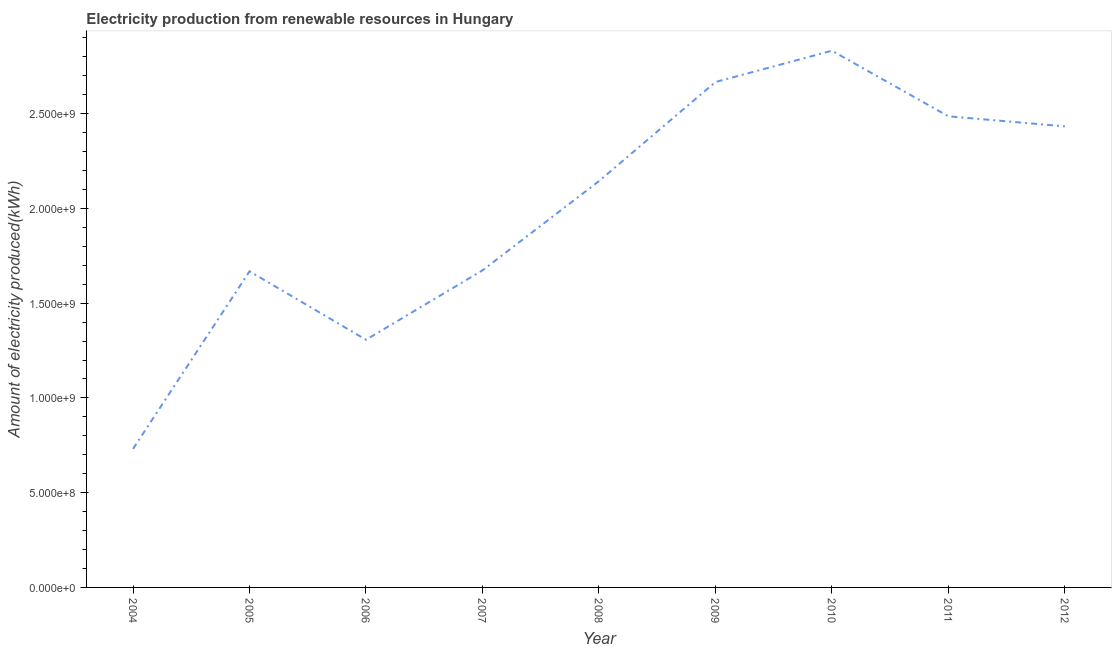What is the amount of electricity produced in 2006?
Make the answer very short. 1.31e+09. Across all years, what is the maximum amount of electricity produced?
Make the answer very short. 2.83e+09. Across all years, what is the minimum amount of electricity produced?
Provide a succinct answer. 7.31e+08. In which year was the amount of electricity produced minimum?
Give a very brief answer. 2004. What is the sum of the amount of electricity produced?
Provide a short and direct response. 1.79e+1. What is the difference between the amount of electricity produced in 2010 and 2012?
Your response must be concise. 3.99e+08. What is the average amount of electricity produced per year?
Provide a succinct answer. 1.99e+09. What is the median amount of electricity produced?
Provide a short and direct response. 2.14e+09. What is the ratio of the amount of electricity produced in 2004 to that in 2006?
Make the answer very short. 0.56. Is the amount of electricity produced in 2007 less than that in 2008?
Offer a very short reply. Yes. Is the difference between the amount of electricity produced in 2005 and 2007 greater than the difference between any two years?
Make the answer very short. No. What is the difference between the highest and the second highest amount of electricity produced?
Keep it short and to the point. 1.65e+08. What is the difference between the highest and the lowest amount of electricity produced?
Keep it short and to the point. 2.10e+09. In how many years, is the amount of electricity produced greater than the average amount of electricity produced taken over all years?
Give a very brief answer. 5. Does the amount of electricity produced monotonically increase over the years?
Your answer should be compact. No. Does the graph contain any zero values?
Give a very brief answer. No. What is the title of the graph?
Offer a terse response. Electricity production from renewable resources in Hungary. What is the label or title of the Y-axis?
Give a very brief answer. Amount of electricity produced(kWh). What is the Amount of electricity produced(kWh) in 2004?
Give a very brief answer. 7.31e+08. What is the Amount of electricity produced(kWh) in 2005?
Keep it short and to the point. 1.67e+09. What is the Amount of electricity produced(kWh) of 2006?
Your answer should be compact. 1.31e+09. What is the Amount of electricity produced(kWh) of 2007?
Give a very brief answer. 1.67e+09. What is the Amount of electricity produced(kWh) in 2008?
Your answer should be very brief. 2.14e+09. What is the Amount of electricity produced(kWh) in 2009?
Keep it short and to the point. 2.67e+09. What is the Amount of electricity produced(kWh) of 2010?
Give a very brief answer. 2.83e+09. What is the Amount of electricity produced(kWh) of 2011?
Give a very brief answer. 2.49e+09. What is the Amount of electricity produced(kWh) in 2012?
Provide a succinct answer. 2.43e+09. What is the difference between the Amount of electricity produced(kWh) in 2004 and 2005?
Your response must be concise. -9.37e+08. What is the difference between the Amount of electricity produced(kWh) in 2004 and 2006?
Provide a succinct answer. -5.76e+08. What is the difference between the Amount of electricity produced(kWh) in 2004 and 2007?
Your answer should be very brief. -9.42e+08. What is the difference between the Amount of electricity produced(kWh) in 2004 and 2008?
Ensure brevity in your answer.  -1.41e+09. What is the difference between the Amount of electricity produced(kWh) in 2004 and 2009?
Give a very brief answer. -1.94e+09. What is the difference between the Amount of electricity produced(kWh) in 2004 and 2010?
Provide a short and direct response. -2.10e+09. What is the difference between the Amount of electricity produced(kWh) in 2004 and 2011?
Offer a terse response. -1.76e+09. What is the difference between the Amount of electricity produced(kWh) in 2004 and 2012?
Your response must be concise. -1.70e+09. What is the difference between the Amount of electricity produced(kWh) in 2005 and 2006?
Your response must be concise. 3.61e+08. What is the difference between the Amount of electricity produced(kWh) in 2005 and 2007?
Give a very brief answer. -5.00e+06. What is the difference between the Amount of electricity produced(kWh) in 2005 and 2008?
Make the answer very short. -4.76e+08. What is the difference between the Amount of electricity produced(kWh) in 2005 and 2009?
Your response must be concise. -9.99e+08. What is the difference between the Amount of electricity produced(kWh) in 2005 and 2010?
Keep it short and to the point. -1.16e+09. What is the difference between the Amount of electricity produced(kWh) in 2005 and 2011?
Your response must be concise. -8.18e+08. What is the difference between the Amount of electricity produced(kWh) in 2005 and 2012?
Your answer should be very brief. -7.65e+08. What is the difference between the Amount of electricity produced(kWh) in 2006 and 2007?
Give a very brief answer. -3.66e+08. What is the difference between the Amount of electricity produced(kWh) in 2006 and 2008?
Provide a succinct answer. -8.37e+08. What is the difference between the Amount of electricity produced(kWh) in 2006 and 2009?
Keep it short and to the point. -1.36e+09. What is the difference between the Amount of electricity produced(kWh) in 2006 and 2010?
Provide a succinct answer. -1.52e+09. What is the difference between the Amount of electricity produced(kWh) in 2006 and 2011?
Offer a very short reply. -1.18e+09. What is the difference between the Amount of electricity produced(kWh) in 2006 and 2012?
Offer a terse response. -1.13e+09. What is the difference between the Amount of electricity produced(kWh) in 2007 and 2008?
Ensure brevity in your answer.  -4.71e+08. What is the difference between the Amount of electricity produced(kWh) in 2007 and 2009?
Your answer should be compact. -9.94e+08. What is the difference between the Amount of electricity produced(kWh) in 2007 and 2010?
Provide a short and direct response. -1.16e+09. What is the difference between the Amount of electricity produced(kWh) in 2007 and 2011?
Offer a terse response. -8.13e+08. What is the difference between the Amount of electricity produced(kWh) in 2007 and 2012?
Your answer should be very brief. -7.60e+08. What is the difference between the Amount of electricity produced(kWh) in 2008 and 2009?
Make the answer very short. -5.23e+08. What is the difference between the Amount of electricity produced(kWh) in 2008 and 2010?
Keep it short and to the point. -6.88e+08. What is the difference between the Amount of electricity produced(kWh) in 2008 and 2011?
Your answer should be very brief. -3.42e+08. What is the difference between the Amount of electricity produced(kWh) in 2008 and 2012?
Offer a terse response. -2.89e+08. What is the difference between the Amount of electricity produced(kWh) in 2009 and 2010?
Your answer should be very brief. -1.65e+08. What is the difference between the Amount of electricity produced(kWh) in 2009 and 2011?
Your response must be concise. 1.81e+08. What is the difference between the Amount of electricity produced(kWh) in 2009 and 2012?
Keep it short and to the point. 2.34e+08. What is the difference between the Amount of electricity produced(kWh) in 2010 and 2011?
Your answer should be compact. 3.46e+08. What is the difference between the Amount of electricity produced(kWh) in 2010 and 2012?
Ensure brevity in your answer.  3.99e+08. What is the difference between the Amount of electricity produced(kWh) in 2011 and 2012?
Your answer should be very brief. 5.30e+07. What is the ratio of the Amount of electricity produced(kWh) in 2004 to that in 2005?
Keep it short and to the point. 0.44. What is the ratio of the Amount of electricity produced(kWh) in 2004 to that in 2006?
Your answer should be compact. 0.56. What is the ratio of the Amount of electricity produced(kWh) in 2004 to that in 2007?
Provide a succinct answer. 0.44. What is the ratio of the Amount of electricity produced(kWh) in 2004 to that in 2008?
Your answer should be compact. 0.34. What is the ratio of the Amount of electricity produced(kWh) in 2004 to that in 2009?
Make the answer very short. 0.27. What is the ratio of the Amount of electricity produced(kWh) in 2004 to that in 2010?
Make the answer very short. 0.26. What is the ratio of the Amount of electricity produced(kWh) in 2004 to that in 2011?
Make the answer very short. 0.29. What is the ratio of the Amount of electricity produced(kWh) in 2005 to that in 2006?
Keep it short and to the point. 1.28. What is the ratio of the Amount of electricity produced(kWh) in 2005 to that in 2007?
Offer a very short reply. 1. What is the ratio of the Amount of electricity produced(kWh) in 2005 to that in 2008?
Your response must be concise. 0.78. What is the ratio of the Amount of electricity produced(kWh) in 2005 to that in 2009?
Keep it short and to the point. 0.62. What is the ratio of the Amount of electricity produced(kWh) in 2005 to that in 2010?
Offer a very short reply. 0.59. What is the ratio of the Amount of electricity produced(kWh) in 2005 to that in 2011?
Give a very brief answer. 0.67. What is the ratio of the Amount of electricity produced(kWh) in 2005 to that in 2012?
Provide a short and direct response. 0.69. What is the ratio of the Amount of electricity produced(kWh) in 2006 to that in 2007?
Ensure brevity in your answer.  0.78. What is the ratio of the Amount of electricity produced(kWh) in 2006 to that in 2008?
Offer a terse response. 0.61. What is the ratio of the Amount of electricity produced(kWh) in 2006 to that in 2009?
Offer a terse response. 0.49. What is the ratio of the Amount of electricity produced(kWh) in 2006 to that in 2010?
Offer a terse response. 0.46. What is the ratio of the Amount of electricity produced(kWh) in 2006 to that in 2011?
Offer a very short reply. 0.53. What is the ratio of the Amount of electricity produced(kWh) in 2006 to that in 2012?
Your answer should be compact. 0.54. What is the ratio of the Amount of electricity produced(kWh) in 2007 to that in 2008?
Offer a very short reply. 0.78. What is the ratio of the Amount of electricity produced(kWh) in 2007 to that in 2009?
Your response must be concise. 0.63. What is the ratio of the Amount of electricity produced(kWh) in 2007 to that in 2010?
Make the answer very short. 0.59. What is the ratio of the Amount of electricity produced(kWh) in 2007 to that in 2011?
Provide a succinct answer. 0.67. What is the ratio of the Amount of electricity produced(kWh) in 2007 to that in 2012?
Give a very brief answer. 0.69. What is the ratio of the Amount of electricity produced(kWh) in 2008 to that in 2009?
Your answer should be compact. 0.8. What is the ratio of the Amount of electricity produced(kWh) in 2008 to that in 2010?
Your response must be concise. 0.76. What is the ratio of the Amount of electricity produced(kWh) in 2008 to that in 2011?
Your answer should be very brief. 0.86. What is the ratio of the Amount of electricity produced(kWh) in 2008 to that in 2012?
Offer a very short reply. 0.88. What is the ratio of the Amount of electricity produced(kWh) in 2009 to that in 2010?
Your answer should be compact. 0.94. What is the ratio of the Amount of electricity produced(kWh) in 2009 to that in 2011?
Provide a succinct answer. 1.07. What is the ratio of the Amount of electricity produced(kWh) in 2009 to that in 2012?
Provide a short and direct response. 1.1. What is the ratio of the Amount of electricity produced(kWh) in 2010 to that in 2011?
Ensure brevity in your answer.  1.14. What is the ratio of the Amount of electricity produced(kWh) in 2010 to that in 2012?
Your answer should be compact. 1.16. 